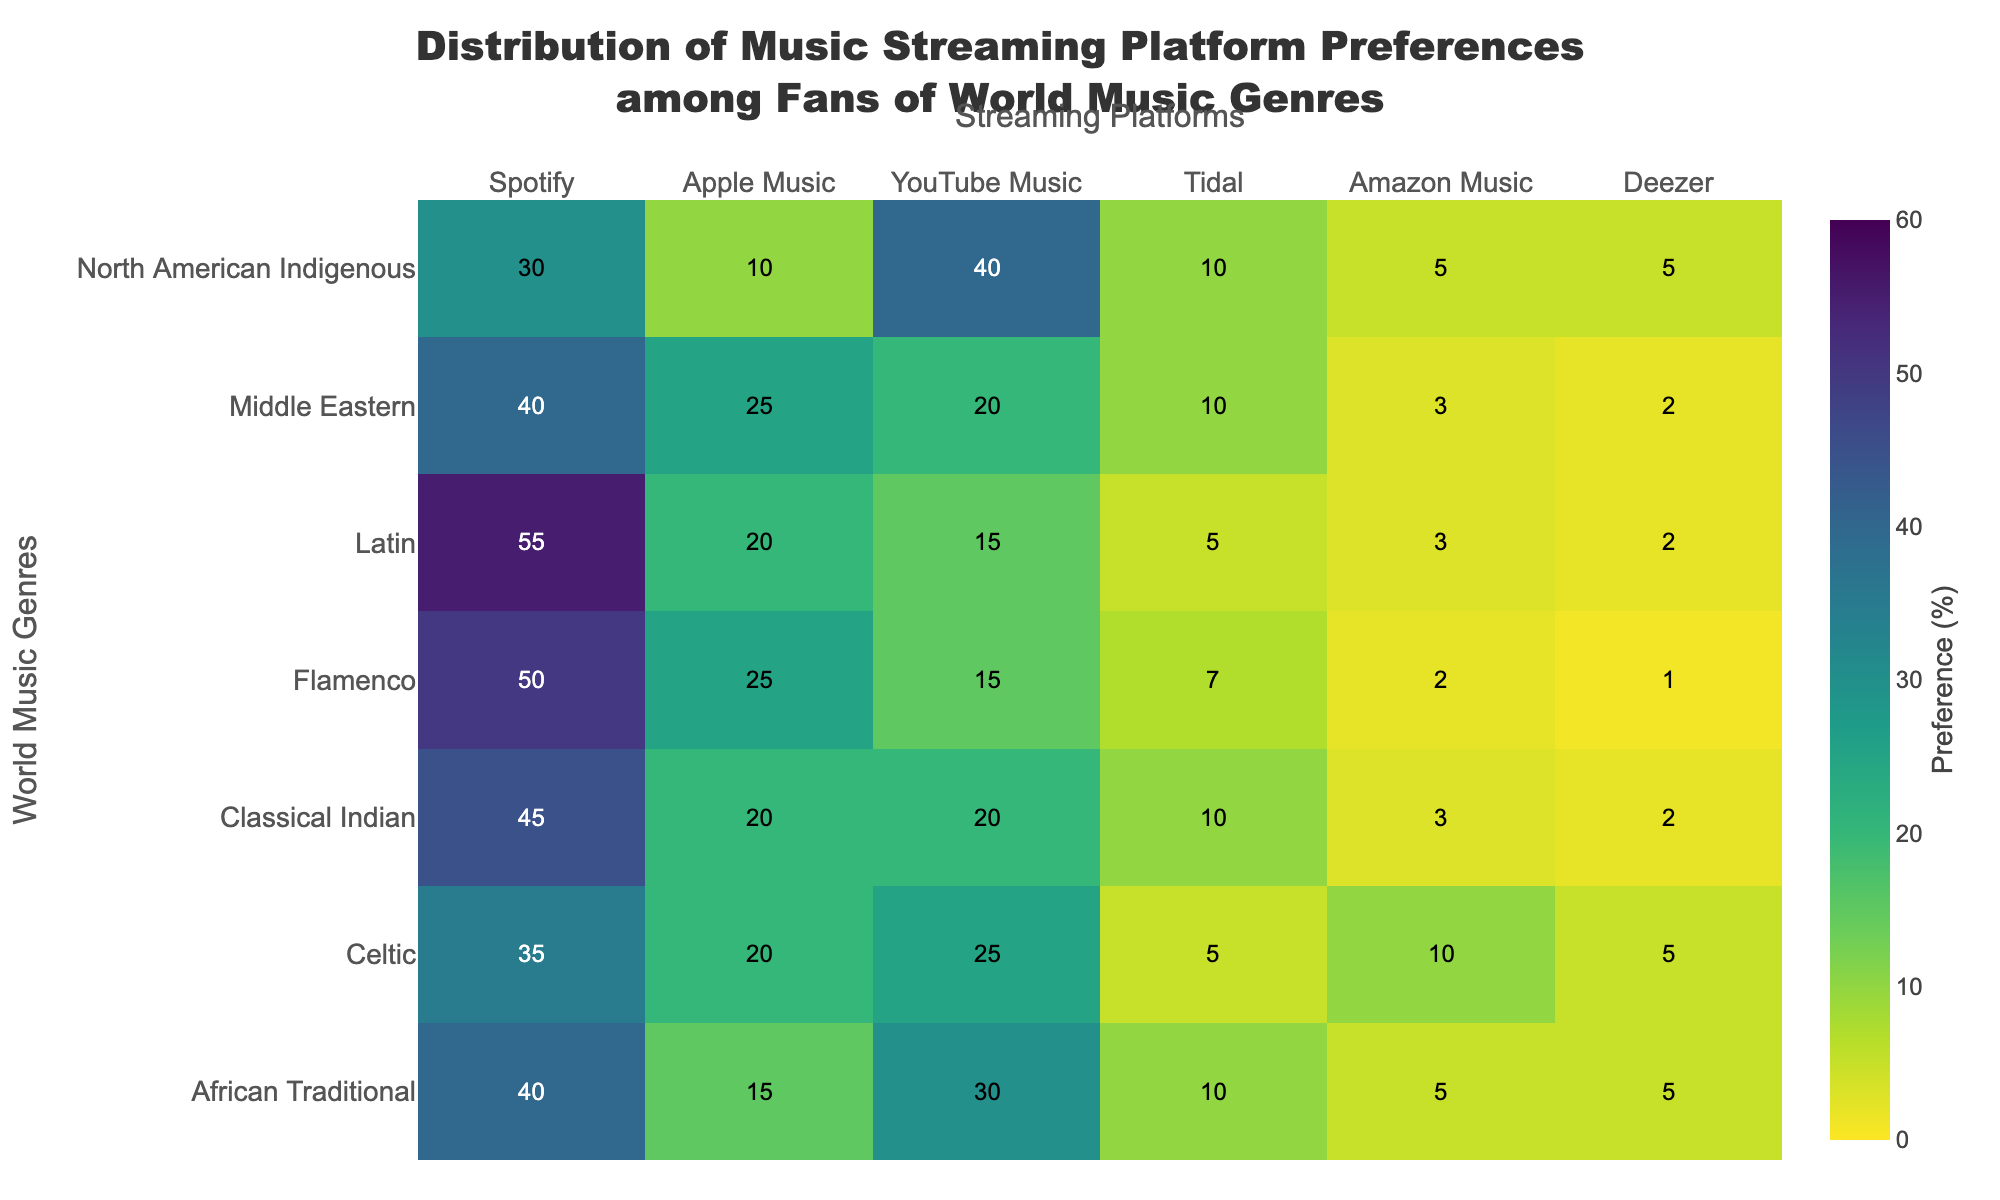What is the most preferred music streaming platform for fans of Latin music? Look at the row labeled "Latin" in the heatmap and identify the highest value under the columns representing the streaming platforms. The highest value is 55, which corresponds to Spotify.
Answer: Spotify Which streaming platform has the lowest preference percentage for Classical Indian music? Examine the row labeled "Classical Indian" and identify the smallest value among the different streaming platform columns. The lowest value is 2, which corresponds to Deezer.
Answer: Deezer How does the preference for YouTube Music compare between African Traditional and North American Indigenous music genres? Check the row for "African Traditional" and the column for "YouTube Music" to find the value 30. For "North American Indigenous," find the value 40 in the same column. Compare these values: 40 is greater than 30.
Answer: It is higher for North American Indigenous Which music genre has the highest preference percentage for Tidal? Find the column labeled "Tidal" and look for the highest number in that column. The highest value is 10, which is shared by "African Traditional," "Classical Indian," and "North American Indigenous" genres.
Answer: African Traditional, Classical Indian, North American Indigenous What is the average preference percentage for Apple Music across all genres? Sum the values in the column "Apple Music": 15 + 20 + 20 + 25 + 20 + 25 + 10 = 135. Divide by the number of genres, which is 7: 135 / 7 ≈ 19.3.
Answer: ≈ 19.3 Which genre shows the least preference for Spotify? Check the values in the "Spotify" column and find the smallest number. The smallest value is 30, corresponding to "North American Indigenous."
Answer: North American Indigenous For the genre Flamenco, how much higher is the preference for Spotify than for Deezer? Locate the value for "Flamenco" under "Spotify" (50) and "Deezer" (1). Subtract the smaller number from the larger: 50 - 1 = 49.
Answer: 49 Compare the preference for Amazon Music between Celtic and Middle Eastern music. Which one is higher and by how much? For "Celtic," find the value in the "Amazon Music" column (10). For "Middle Eastern," find the value (3). Subtract the smaller value from the larger: 10 - 3 = 7. "Celtic" has a higher preference.
Answer: Celtic by 7 Which streaming platform has a 25% preference for Celtic music? Identify the row labeled "Celtic" and find the value 25, which corresponds to YouTube Music.
Answer: YouTube Music 